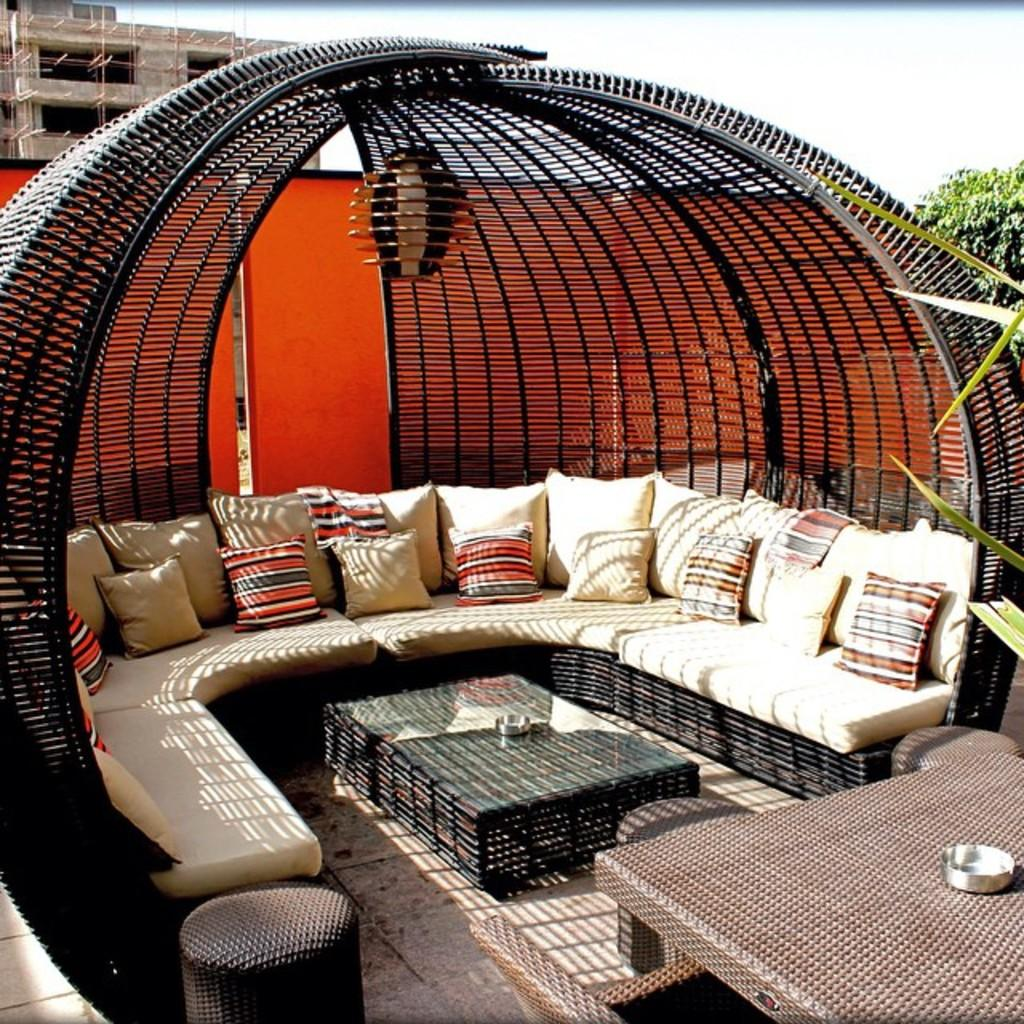What can be seen at the top of the image? The sky is visible at the top of the image. What is happening in the background of the image? There is a building under construction in the background of the image. What type of vegetation is present in the image? There is a tree in the image. What type of furniture can be seen in the image? There is a sofa in the image. What is placed on the sofa? There are pillows on the sofa. What other objects are present in the image? There are tables in the image. What type of paste is being used to construct the building in the image? There is no indication of any paste being used in the construction of the building in the image. How many bottles can be seen on the table in the image? There is no mention of any bottles in the image. 